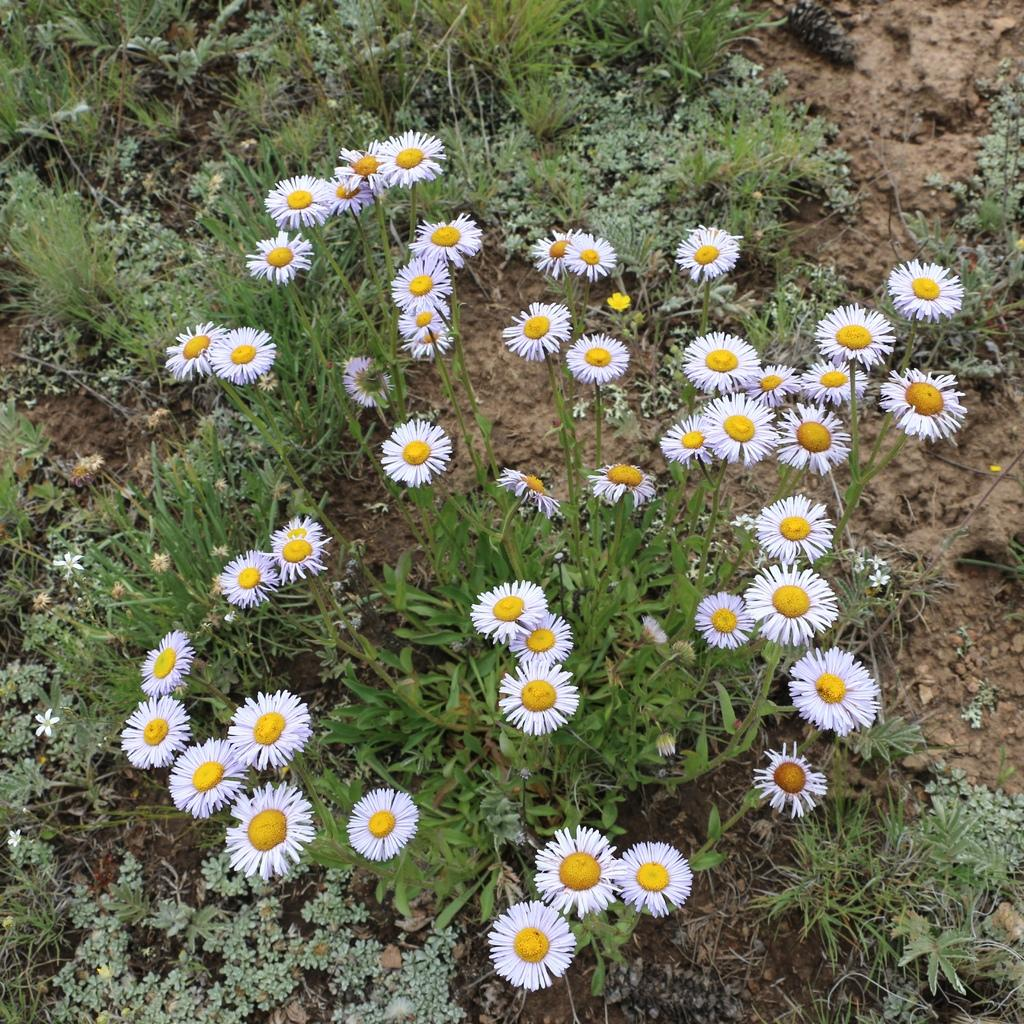What is the main subject in the center of the image? There are flower plants in the center of the image. What else can be seen in the image besides the flower plants? There is greenery visible in the image. Can you hear the baby laughing in the image? There is no baby or laughter present in the image; it features flower plants and greenery. 